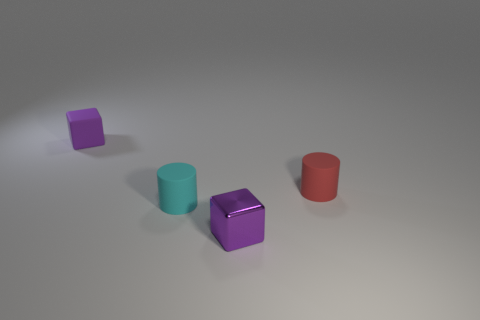Subtract all purple blocks. How many were subtracted if there are1purple blocks left? 1 Add 4 blue rubber blocks. How many objects exist? 8 Subtract all green shiny objects. Subtract all tiny purple rubber things. How many objects are left? 3 Add 4 small red matte cylinders. How many small red matte cylinders are left? 5 Add 4 small red blocks. How many small red blocks exist? 4 Subtract 0 gray blocks. How many objects are left? 4 